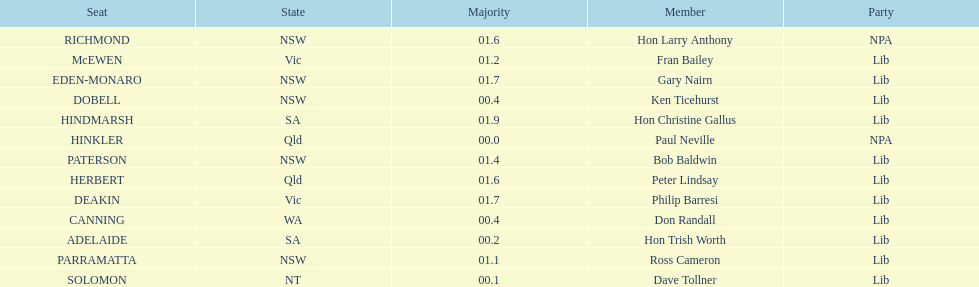Did fran bailey originate from victoria or western australia? Vic. 